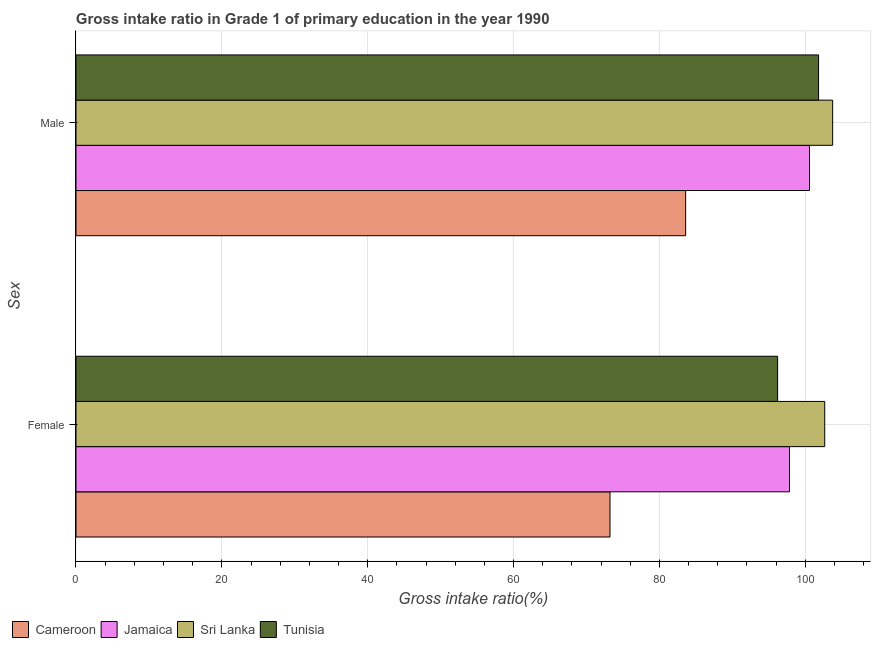How many groups of bars are there?
Offer a very short reply. 2. Are the number of bars per tick equal to the number of legend labels?
Your response must be concise. Yes. Are the number of bars on each tick of the Y-axis equal?
Offer a terse response. Yes. How many bars are there on the 1st tick from the top?
Provide a short and direct response. 4. What is the label of the 2nd group of bars from the top?
Keep it short and to the point. Female. What is the gross intake ratio(female) in Cameroon?
Provide a short and direct response. 73.22. Across all countries, what is the maximum gross intake ratio(male)?
Offer a terse response. 103.75. Across all countries, what is the minimum gross intake ratio(male)?
Your answer should be compact. 83.59. In which country was the gross intake ratio(female) maximum?
Ensure brevity in your answer.  Sri Lanka. In which country was the gross intake ratio(male) minimum?
Your answer should be very brief. Cameroon. What is the total gross intake ratio(female) in the graph?
Provide a short and direct response. 369.91. What is the difference between the gross intake ratio(female) in Jamaica and that in Tunisia?
Give a very brief answer. 1.63. What is the difference between the gross intake ratio(female) in Tunisia and the gross intake ratio(male) in Jamaica?
Offer a terse response. -4.37. What is the average gross intake ratio(male) per country?
Offer a very short reply. 97.43. What is the difference between the gross intake ratio(male) and gross intake ratio(female) in Sri Lanka?
Your answer should be very brief. 1.09. In how many countries, is the gross intake ratio(male) greater than 52 %?
Ensure brevity in your answer.  4. What is the ratio of the gross intake ratio(male) in Tunisia to that in Sri Lanka?
Provide a succinct answer. 0.98. What does the 4th bar from the top in Female represents?
Your answer should be very brief. Cameroon. What does the 1st bar from the bottom in Male represents?
Offer a terse response. Cameroon. Are all the bars in the graph horizontal?
Provide a short and direct response. Yes. How many countries are there in the graph?
Your response must be concise. 4. Does the graph contain grids?
Make the answer very short. Yes. Where does the legend appear in the graph?
Provide a short and direct response. Bottom left. How are the legend labels stacked?
Give a very brief answer. Horizontal. What is the title of the graph?
Your answer should be compact. Gross intake ratio in Grade 1 of primary education in the year 1990. What is the label or title of the X-axis?
Keep it short and to the point. Gross intake ratio(%). What is the label or title of the Y-axis?
Give a very brief answer. Sex. What is the Gross intake ratio(%) in Cameroon in Female?
Offer a very short reply. 73.22. What is the Gross intake ratio(%) in Jamaica in Female?
Provide a succinct answer. 97.83. What is the Gross intake ratio(%) in Sri Lanka in Female?
Give a very brief answer. 102.66. What is the Gross intake ratio(%) in Tunisia in Female?
Your response must be concise. 96.2. What is the Gross intake ratio(%) in Cameroon in Male?
Make the answer very short. 83.59. What is the Gross intake ratio(%) in Jamaica in Male?
Your response must be concise. 100.58. What is the Gross intake ratio(%) in Sri Lanka in Male?
Offer a very short reply. 103.75. What is the Gross intake ratio(%) in Tunisia in Male?
Offer a very short reply. 101.82. Across all Sex, what is the maximum Gross intake ratio(%) of Cameroon?
Ensure brevity in your answer.  83.59. Across all Sex, what is the maximum Gross intake ratio(%) in Jamaica?
Give a very brief answer. 100.58. Across all Sex, what is the maximum Gross intake ratio(%) in Sri Lanka?
Provide a short and direct response. 103.75. Across all Sex, what is the maximum Gross intake ratio(%) in Tunisia?
Provide a succinct answer. 101.82. Across all Sex, what is the minimum Gross intake ratio(%) of Cameroon?
Your response must be concise. 73.22. Across all Sex, what is the minimum Gross intake ratio(%) of Jamaica?
Ensure brevity in your answer.  97.83. Across all Sex, what is the minimum Gross intake ratio(%) in Sri Lanka?
Ensure brevity in your answer.  102.66. Across all Sex, what is the minimum Gross intake ratio(%) in Tunisia?
Offer a terse response. 96.2. What is the total Gross intake ratio(%) in Cameroon in the graph?
Give a very brief answer. 156.81. What is the total Gross intake ratio(%) in Jamaica in the graph?
Provide a short and direct response. 198.41. What is the total Gross intake ratio(%) in Sri Lanka in the graph?
Provide a short and direct response. 206.41. What is the total Gross intake ratio(%) of Tunisia in the graph?
Provide a short and direct response. 198.02. What is the difference between the Gross intake ratio(%) of Cameroon in Female and that in Male?
Ensure brevity in your answer.  -10.37. What is the difference between the Gross intake ratio(%) of Jamaica in Female and that in Male?
Give a very brief answer. -2.75. What is the difference between the Gross intake ratio(%) of Sri Lanka in Female and that in Male?
Ensure brevity in your answer.  -1.09. What is the difference between the Gross intake ratio(%) of Tunisia in Female and that in Male?
Your response must be concise. -5.61. What is the difference between the Gross intake ratio(%) of Cameroon in Female and the Gross intake ratio(%) of Jamaica in Male?
Provide a short and direct response. -27.36. What is the difference between the Gross intake ratio(%) of Cameroon in Female and the Gross intake ratio(%) of Sri Lanka in Male?
Give a very brief answer. -30.53. What is the difference between the Gross intake ratio(%) in Cameroon in Female and the Gross intake ratio(%) in Tunisia in Male?
Your answer should be compact. -28.6. What is the difference between the Gross intake ratio(%) of Jamaica in Female and the Gross intake ratio(%) of Sri Lanka in Male?
Ensure brevity in your answer.  -5.92. What is the difference between the Gross intake ratio(%) of Jamaica in Female and the Gross intake ratio(%) of Tunisia in Male?
Keep it short and to the point. -3.99. What is the difference between the Gross intake ratio(%) of Sri Lanka in Female and the Gross intake ratio(%) of Tunisia in Male?
Give a very brief answer. 0.85. What is the average Gross intake ratio(%) in Cameroon per Sex?
Provide a succinct answer. 78.41. What is the average Gross intake ratio(%) of Jamaica per Sex?
Offer a very short reply. 99.2. What is the average Gross intake ratio(%) in Sri Lanka per Sex?
Offer a very short reply. 103.2. What is the average Gross intake ratio(%) in Tunisia per Sex?
Make the answer very short. 99.01. What is the difference between the Gross intake ratio(%) in Cameroon and Gross intake ratio(%) in Jamaica in Female?
Make the answer very short. -24.61. What is the difference between the Gross intake ratio(%) of Cameroon and Gross intake ratio(%) of Sri Lanka in Female?
Make the answer very short. -29.44. What is the difference between the Gross intake ratio(%) in Cameroon and Gross intake ratio(%) in Tunisia in Female?
Ensure brevity in your answer.  -22.98. What is the difference between the Gross intake ratio(%) in Jamaica and Gross intake ratio(%) in Sri Lanka in Female?
Your answer should be compact. -4.83. What is the difference between the Gross intake ratio(%) of Jamaica and Gross intake ratio(%) of Tunisia in Female?
Make the answer very short. 1.63. What is the difference between the Gross intake ratio(%) of Sri Lanka and Gross intake ratio(%) of Tunisia in Female?
Offer a terse response. 6.46. What is the difference between the Gross intake ratio(%) of Cameroon and Gross intake ratio(%) of Jamaica in Male?
Ensure brevity in your answer.  -16.99. What is the difference between the Gross intake ratio(%) of Cameroon and Gross intake ratio(%) of Sri Lanka in Male?
Provide a short and direct response. -20.16. What is the difference between the Gross intake ratio(%) in Cameroon and Gross intake ratio(%) in Tunisia in Male?
Provide a succinct answer. -18.23. What is the difference between the Gross intake ratio(%) in Jamaica and Gross intake ratio(%) in Sri Lanka in Male?
Offer a terse response. -3.17. What is the difference between the Gross intake ratio(%) in Jamaica and Gross intake ratio(%) in Tunisia in Male?
Keep it short and to the point. -1.24. What is the difference between the Gross intake ratio(%) in Sri Lanka and Gross intake ratio(%) in Tunisia in Male?
Provide a succinct answer. 1.93. What is the ratio of the Gross intake ratio(%) of Cameroon in Female to that in Male?
Ensure brevity in your answer.  0.88. What is the ratio of the Gross intake ratio(%) of Jamaica in Female to that in Male?
Provide a succinct answer. 0.97. What is the ratio of the Gross intake ratio(%) of Sri Lanka in Female to that in Male?
Provide a succinct answer. 0.99. What is the ratio of the Gross intake ratio(%) in Tunisia in Female to that in Male?
Your answer should be compact. 0.94. What is the difference between the highest and the second highest Gross intake ratio(%) in Cameroon?
Make the answer very short. 10.37. What is the difference between the highest and the second highest Gross intake ratio(%) of Jamaica?
Provide a short and direct response. 2.75. What is the difference between the highest and the second highest Gross intake ratio(%) of Sri Lanka?
Provide a short and direct response. 1.09. What is the difference between the highest and the second highest Gross intake ratio(%) of Tunisia?
Ensure brevity in your answer.  5.61. What is the difference between the highest and the lowest Gross intake ratio(%) of Cameroon?
Keep it short and to the point. 10.37. What is the difference between the highest and the lowest Gross intake ratio(%) of Jamaica?
Offer a very short reply. 2.75. What is the difference between the highest and the lowest Gross intake ratio(%) in Sri Lanka?
Provide a succinct answer. 1.09. What is the difference between the highest and the lowest Gross intake ratio(%) in Tunisia?
Ensure brevity in your answer.  5.61. 